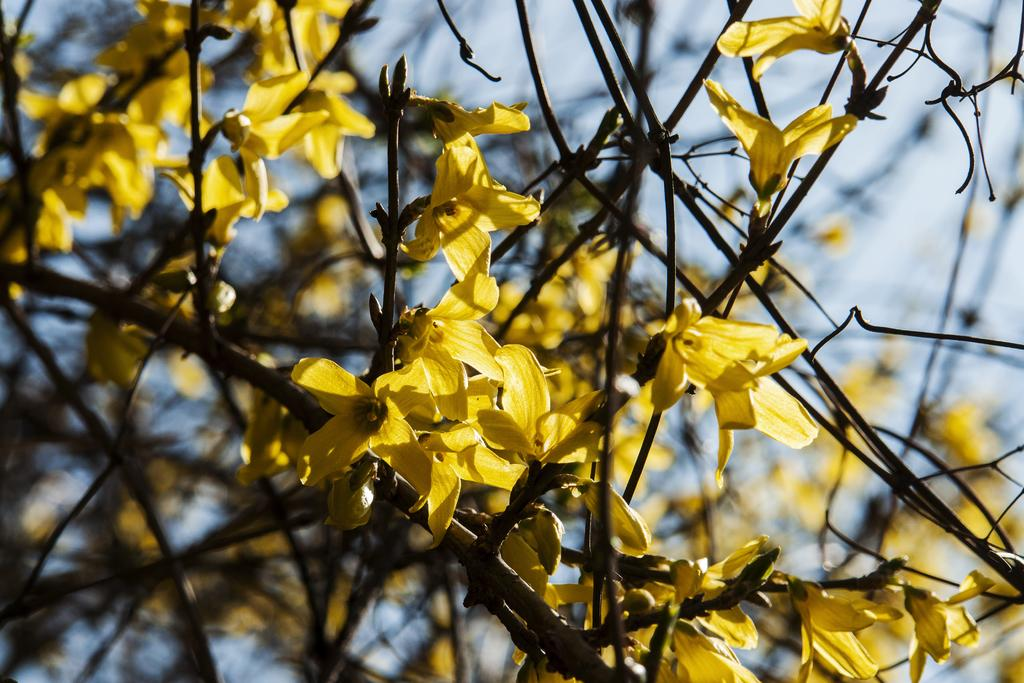What type of living organisms can be seen in the image? There are flowers in the image. What color are the flowers? The flowers are yellow. What else can be seen in the image besides the flowers? There are stems of a plant in the image. What is visible in the background of the image? The sky is visible in the background of the image. What type of cream is being served on the plate in the image? There is no plate or cream present in the image; it features yellow flowers and stems of a plant. 